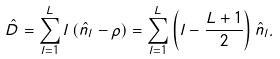Convert formula to latex. <formula><loc_0><loc_0><loc_500><loc_500>\hat { D } = \sum _ { l = 1 } ^ { L } l \left ( \hat { n } _ { l } - \rho \right ) = \sum _ { l = 1 } ^ { L } \left ( l - \frac { L + 1 } { 2 } \right ) \hat { n } _ { l } .</formula> 